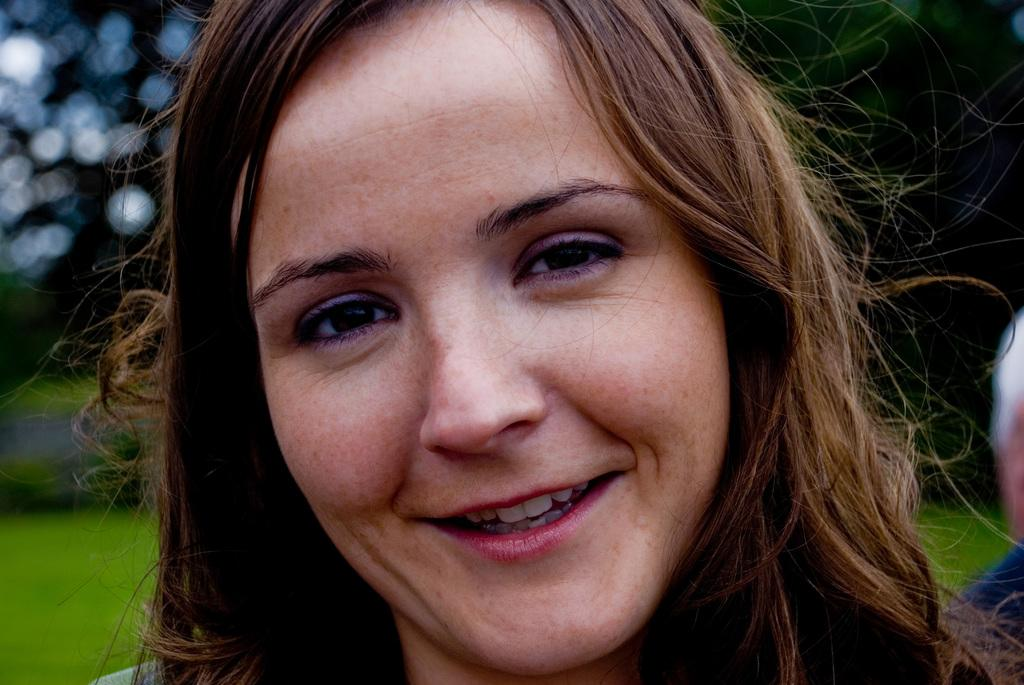Who is the main subject in the image? There is a woman in the image. What part of the woman can be seen? Only her face is visible in the image. What expression does the woman have? The woman is smiling. Can you describe the background of the image? The background of the image is blurry. What type of animals can be seen at the zoo in the image? There is no zoo or animals present in the image; it features a woman with a blurry background. How is the oatmeal being prepared in the image? There is no oatmeal present in the image, so it cannot be determined how it might be prepared. 